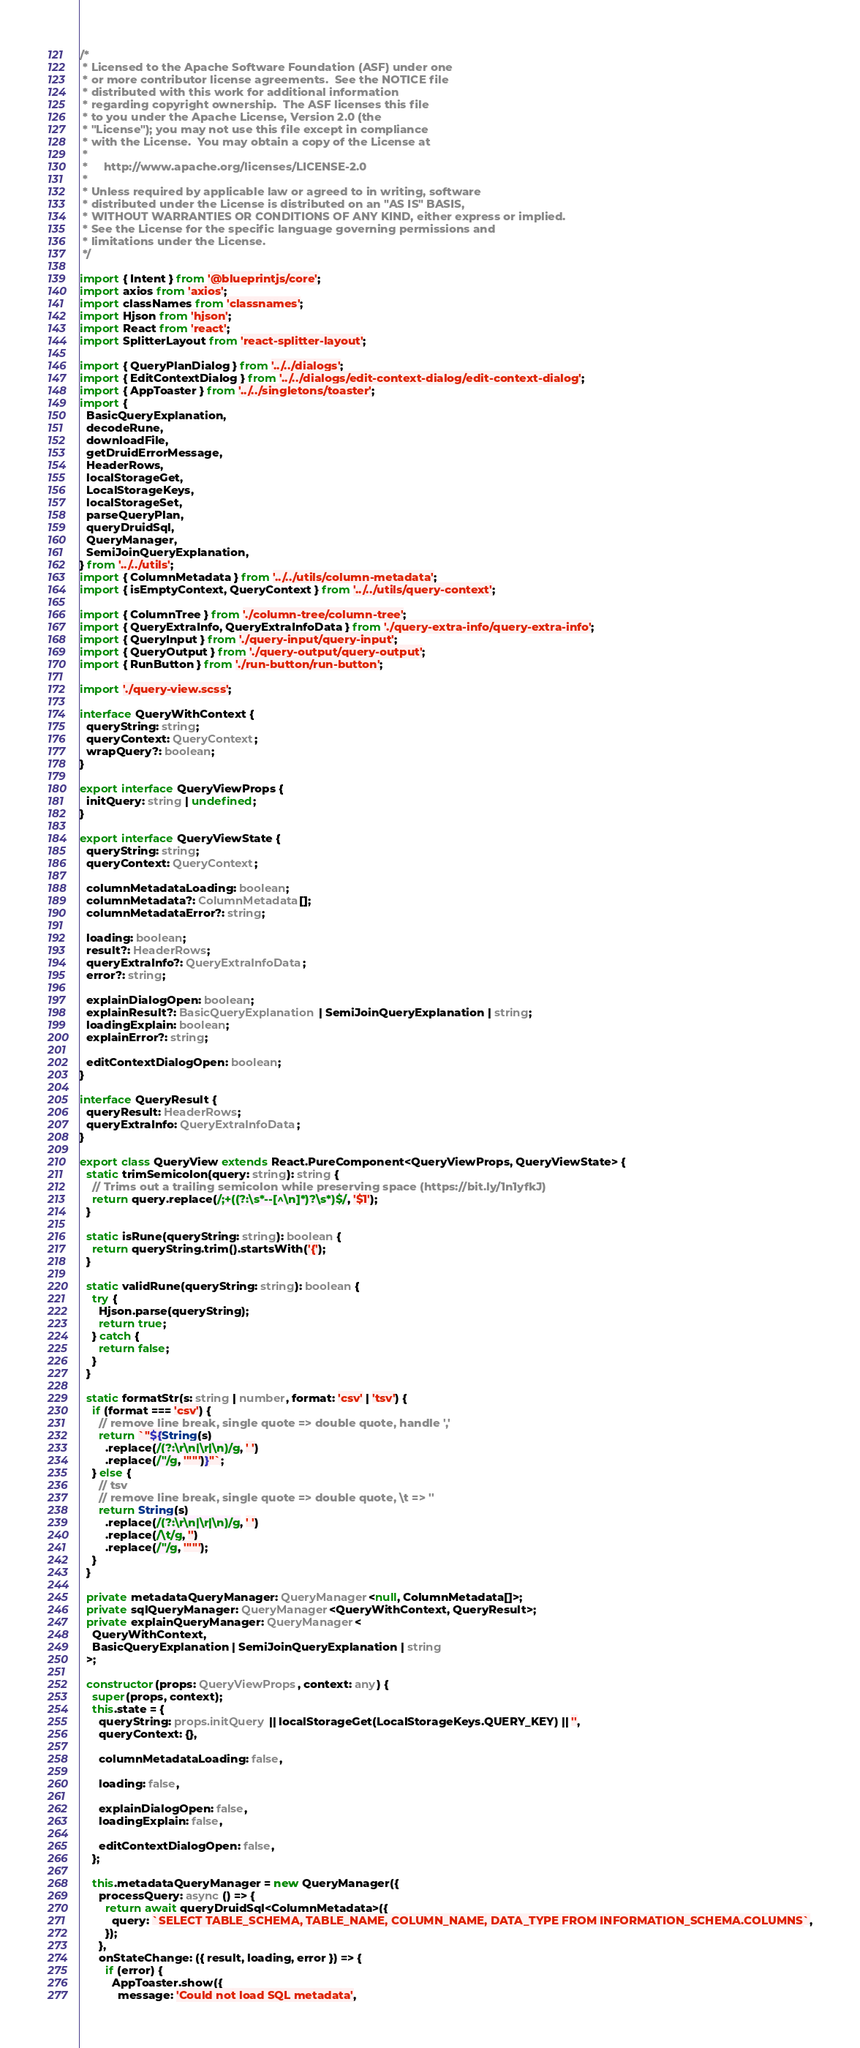Convert code to text. <code><loc_0><loc_0><loc_500><loc_500><_TypeScript_>/*
 * Licensed to the Apache Software Foundation (ASF) under one
 * or more contributor license agreements.  See the NOTICE file
 * distributed with this work for additional information
 * regarding copyright ownership.  The ASF licenses this file
 * to you under the Apache License, Version 2.0 (the
 * "License"); you may not use this file except in compliance
 * with the License.  You may obtain a copy of the License at
 *
 *     http://www.apache.org/licenses/LICENSE-2.0
 *
 * Unless required by applicable law or agreed to in writing, software
 * distributed under the License is distributed on an "AS IS" BASIS,
 * WITHOUT WARRANTIES OR CONDITIONS OF ANY KIND, either express or implied.
 * See the License for the specific language governing permissions and
 * limitations under the License.
 */

import { Intent } from '@blueprintjs/core';
import axios from 'axios';
import classNames from 'classnames';
import Hjson from 'hjson';
import React from 'react';
import SplitterLayout from 'react-splitter-layout';

import { QueryPlanDialog } from '../../dialogs';
import { EditContextDialog } from '../../dialogs/edit-context-dialog/edit-context-dialog';
import { AppToaster } from '../../singletons/toaster';
import {
  BasicQueryExplanation,
  decodeRune,
  downloadFile,
  getDruidErrorMessage,
  HeaderRows,
  localStorageGet,
  LocalStorageKeys,
  localStorageSet,
  parseQueryPlan,
  queryDruidSql,
  QueryManager,
  SemiJoinQueryExplanation,
} from '../../utils';
import { ColumnMetadata } from '../../utils/column-metadata';
import { isEmptyContext, QueryContext } from '../../utils/query-context';

import { ColumnTree } from './column-tree/column-tree';
import { QueryExtraInfo, QueryExtraInfoData } from './query-extra-info/query-extra-info';
import { QueryInput } from './query-input/query-input';
import { QueryOutput } from './query-output/query-output';
import { RunButton } from './run-button/run-button';

import './query-view.scss';

interface QueryWithContext {
  queryString: string;
  queryContext: QueryContext;
  wrapQuery?: boolean;
}

export interface QueryViewProps {
  initQuery: string | undefined;
}

export interface QueryViewState {
  queryString: string;
  queryContext: QueryContext;

  columnMetadataLoading: boolean;
  columnMetadata?: ColumnMetadata[];
  columnMetadataError?: string;

  loading: boolean;
  result?: HeaderRows;
  queryExtraInfo?: QueryExtraInfoData;
  error?: string;

  explainDialogOpen: boolean;
  explainResult?: BasicQueryExplanation | SemiJoinQueryExplanation | string;
  loadingExplain: boolean;
  explainError?: string;

  editContextDialogOpen: boolean;
}

interface QueryResult {
  queryResult: HeaderRows;
  queryExtraInfo: QueryExtraInfoData;
}

export class QueryView extends React.PureComponent<QueryViewProps, QueryViewState> {
  static trimSemicolon(query: string): string {
    // Trims out a trailing semicolon while preserving space (https://bit.ly/1n1yfkJ)
    return query.replace(/;+((?:\s*--[^\n]*)?\s*)$/, '$1');
  }

  static isRune(queryString: string): boolean {
    return queryString.trim().startsWith('{');
  }

  static validRune(queryString: string): boolean {
    try {
      Hjson.parse(queryString);
      return true;
    } catch {
      return false;
    }
  }

  static formatStr(s: string | number, format: 'csv' | 'tsv') {
    if (format === 'csv') {
      // remove line break, single quote => double quote, handle ','
      return `"${String(s)
        .replace(/(?:\r\n|\r|\n)/g, ' ')
        .replace(/"/g, '""')}"`;
    } else {
      // tsv
      // remove line break, single quote => double quote, \t => ''
      return String(s)
        .replace(/(?:\r\n|\r|\n)/g, ' ')
        .replace(/\t/g, '')
        .replace(/"/g, '""');
    }
  }

  private metadataQueryManager: QueryManager<null, ColumnMetadata[]>;
  private sqlQueryManager: QueryManager<QueryWithContext, QueryResult>;
  private explainQueryManager: QueryManager<
    QueryWithContext,
    BasicQueryExplanation | SemiJoinQueryExplanation | string
  >;

  constructor(props: QueryViewProps, context: any) {
    super(props, context);
    this.state = {
      queryString: props.initQuery || localStorageGet(LocalStorageKeys.QUERY_KEY) || '',
      queryContext: {},

      columnMetadataLoading: false,

      loading: false,

      explainDialogOpen: false,
      loadingExplain: false,

      editContextDialogOpen: false,
    };

    this.metadataQueryManager = new QueryManager({
      processQuery: async () => {
        return await queryDruidSql<ColumnMetadata>({
          query: `SELECT TABLE_SCHEMA, TABLE_NAME, COLUMN_NAME, DATA_TYPE FROM INFORMATION_SCHEMA.COLUMNS`,
        });
      },
      onStateChange: ({ result, loading, error }) => {
        if (error) {
          AppToaster.show({
            message: 'Could not load SQL metadata',</code> 